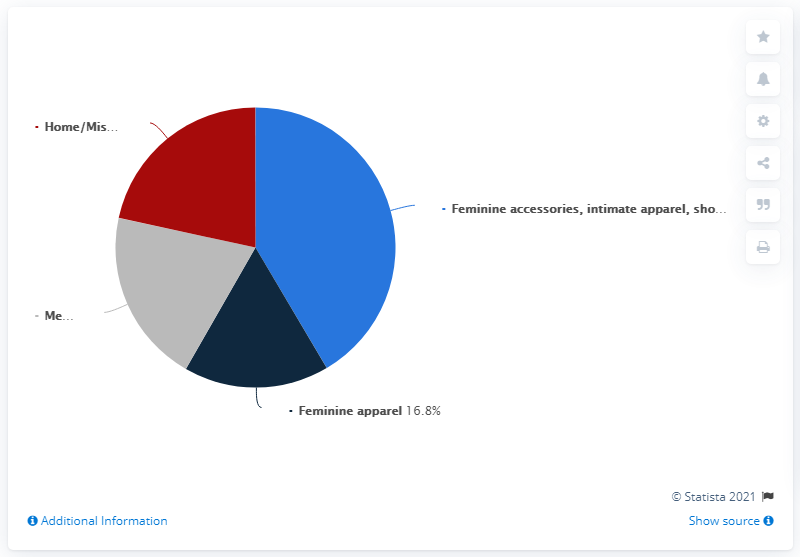Mention a couple of crucial points in this snapshot. Macy Inc. is known for selling a wide variety of products, including feminine accessories, intimate apparel, shoes, and cosmetics. However, the most popular product worldwide is feminine accessories. Macy's, Inc. accounts for 16.8% of the global sales of feminine apparel. 